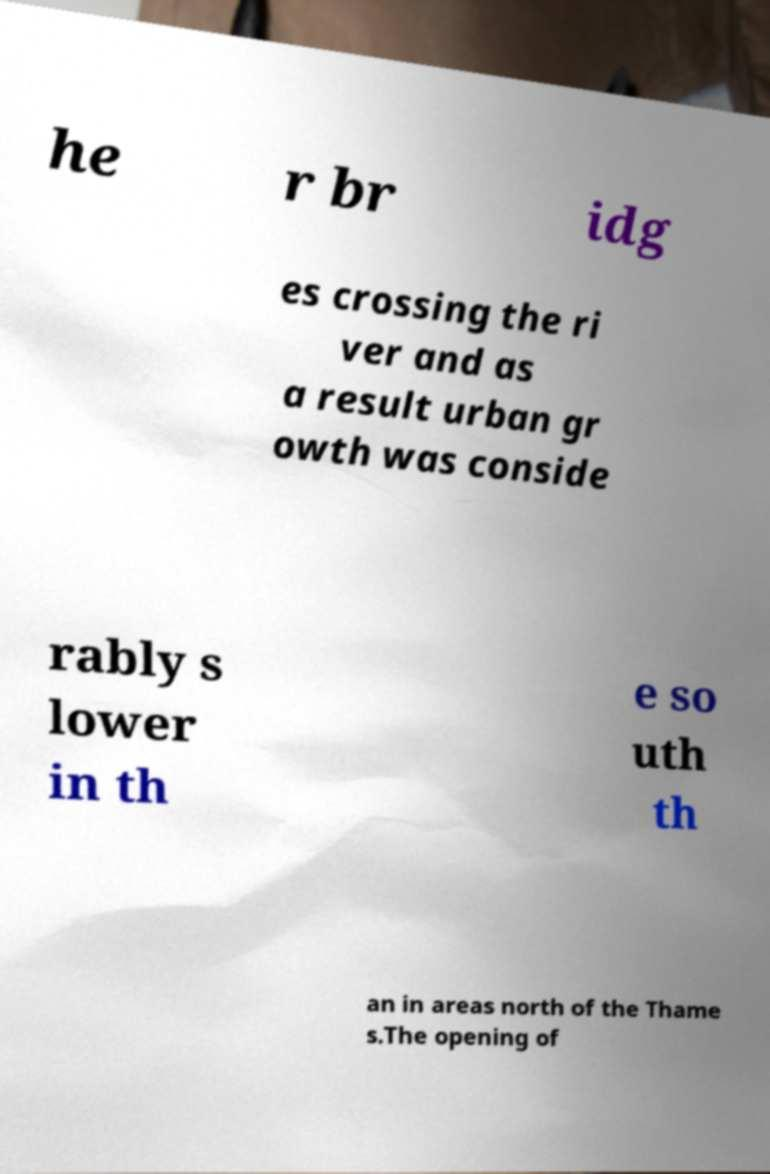For documentation purposes, I need the text within this image transcribed. Could you provide that? he r br idg es crossing the ri ver and as a result urban gr owth was conside rably s lower in th e so uth th an in areas north of the Thame s.The opening of 